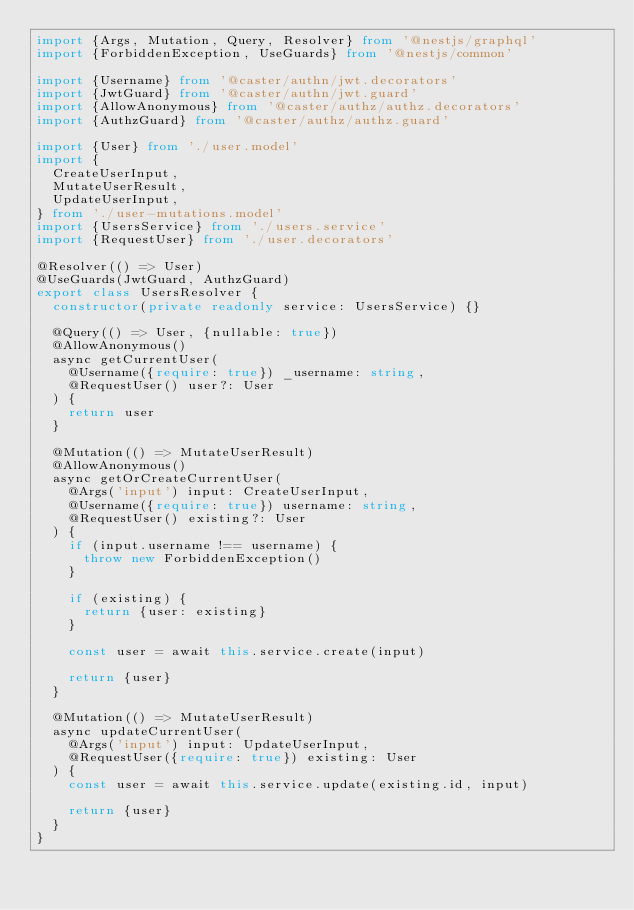<code> <loc_0><loc_0><loc_500><loc_500><_TypeScript_>import {Args, Mutation, Query, Resolver} from '@nestjs/graphql'
import {ForbiddenException, UseGuards} from '@nestjs/common'

import {Username} from '@caster/authn/jwt.decorators'
import {JwtGuard} from '@caster/authn/jwt.guard'
import {AllowAnonymous} from '@caster/authz/authz.decorators'
import {AuthzGuard} from '@caster/authz/authz.guard'

import {User} from './user.model'
import {
  CreateUserInput,
  MutateUserResult,
  UpdateUserInput,
} from './user-mutations.model'
import {UsersService} from './users.service'
import {RequestUser} from './user.decorators'

@Resolver(() => User)
@UseGuards(JwtGuard, AuthzGuard)
export class UsersResolver {
  constructor(private readonly service: UsersService) {}

  @Query(() => User, {nullable: true})
  @AllowAnonymous()
  async getCurrentUser(
    @Username({require: true}) _username: string,
    @RequestUser() user?: User
  ) {
    return user
  }

  @Mutation(() => MutateUserResult)
  @AllowAnonymous()
  async getOrCreateCurrentUser(
    @Args('input') input: CreateUserInput,
    @Username({require: true}) username: string,
    @RequestUser() existing?: User
  ) {
    if (input.username !== username) {
      throw new ForbiddenException()
    }

    if (existing) {
      return {user: existing}
    }

    const user = await this.service.create(input)

    return {user}
  }

  @Mutation(() => MutateUserResult)
  async updateCurrentUser(
    @Args('input') input: UpdateUserInput,
    @RequestUser({require: true}) existing: User
  ) {
    const user = await this.service.update(existing.id, input)

    return {user}
  }
}
</code> 